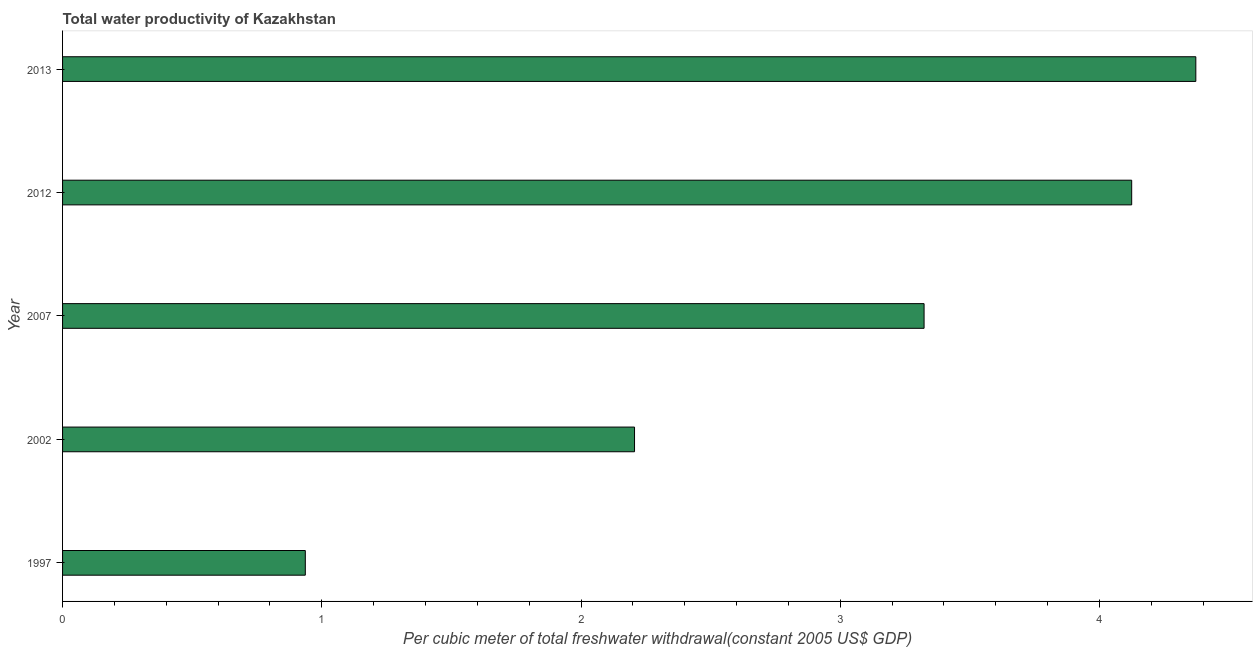Does the graph contain grids?
Provide a short and direct response. No. What is the title of the graph?
Give a very brief answer. Total water productivity of Kazakhstan. What is the label or title of the X-axis?
Your answer should be very brief. Per cubic meter of total freshwater withdrawal(constant 2005 US$ GDP). What is the total water productivity in 2012?
Your response must be concise. 4.12. Across all years, what is the maximum total water productivity?
Your answer should be very brief. 4.37. Across all years, what is the minimum total water productivity?
Offer a terse response. 0.94. What is the sum of the total water productivity?
Offer a terse response. 14.96. What is the difference between the total water productivity in 2012 and 2013?
Provide a short and direct response. -0.25. What is the average total water productivity per year?
Give a very brief answer. 2.99. What is the median total water productivity?
Provide a succinct answer. 3.32. What is the ratio of the total water productivity in 1997 to that in 2012?
Ensure brevity in your answer.  0.23. What is the difference between the highest and the second highest total water productivity?
Your answer should be very brief. 0.25. Is the sum of the total water productivity in 2007 and 2013 greater than the maximum total water productivity across all years?
Offer a very short reply. Yes. What is the difference between the highest and the lowest total water productivity?
Your answer should be very brief. 3.44. In how many years, is the total water productivity greater than the average total water productivity taken over all years?
Make the answer very short. 3. How many years are there in the graph?
Your answer should be compact. 5. Are the values on the major ticks of X-axis written in scientific E-notation?
Give a very brief answer. No. What is the Per cubic meter of total freshwater withdrawal(constant 2005 US$ GDP) of 1997?
Your answer should be compact. 0.94. What is the Per cubic meter of total freshwater withdrawal(constant 2005 US$ GDP) in 2002?
Offer a very short reply. 2.21. What is the Per cubic meter of total freshwater withdrawal(constant 2005 US$ GDP) of 2007?
Offer a terse response. 3.32. What is the Per cubic meter of total freshwater withdrawal(constant 2005 US$ GDP) of 2012?
Offer a very short reply. 4.12. What is the Per cubic meter of total freshwater withdrawal(constant 2005 US$ GDP) in 2013?
Give a very brief answer. 4.37. What is the difference between the Per cubic meter of total freshwater withdrawal(constant 2005 US$ GDP) in 1997 and 2002?
Offer a very short reply. -1.27. What is the difference between the Per cubic meter of total freshwater withdrawal(constant 2005 US$ GDP) in 1997 and 2007?
Give a very brief answer. -2.39. What is the difference between the Per cubic meter of total freshwater withdrawal(constant 2005 US$ GDP) in 1997 and 2012?
Ensure brevity in your answer.  -3.19. What is the difference between the Per cubic meter of total freshwater withdrawal(constant 2005 US$ GDP) in 1997 and 2013?
Ensure brevity in your answer.  -3.44. What is the difference between the Per cubic meter of total freshwater withdrawal(constant 2005 US$ GDP) in 2002 and 2007?
Provide a succinct answer. -1.12. What is the difference between the Per cubic meter of total freshwater withdrawal(constant 2005 US$ GDP) in 2002 and 2012?
Give a very brief answer. -1.92. What is the difference between the Per cubic meter of total freshwater withdrawal(constant 2005 US$ GDP) in 2002 and 2013?
Offer a terse response. -2.17. What is the difference between the Per cubic meter of total freshwater withdrawal(constant 2005 US$ GDP) in 2007 and 2012?
Your answer should be very brief. -0.8. What is the difference between the Per cubic meter of total freshwater withdrawal(constant 2005 US$ GDP) in 2007 and 2013?
Ensure brevity in your answer.  -1.05. What is the difference between the Per cubic meter of total freshwater withdrawal(constant 2005 US$ GDP) in 2012 and 2013?
Ensure brevity in your answer.  -0.25. What is the ratio of the Per cubic meter of total freshwater withdrawal(constant 2005 US$ GDP) in 1997 to that in 2002?
Your response must be concise. 0.42. What is the ratio of the Per cubic meter of total freshwater withdrawal(constant 2005 US$ GDP) in 1997 to that in 2007?
Offer a very short reply. 0.28. What is the ratio of the Per cubic meter of total freshwater withdrawal(constant 2005 US$ GDP) in 1997 to that in 2012?
Provide a short and direct response. 0.23. What is the ratio of the Per cubic meter of total freshwater withdrawal(constant 2005 US$ GDP) in 1997 to that in 2013?
Offer a very short reply. 0.21. What is the ratio of the Per cubic meter of total freshwater withdrawal(constant 2005 US$ GDP) in 2002 to that in 2007?
Make the answer very short. 0.66. What is the ratio of the Per cubic meter of total freshwater withdrawal(constant 2005 US$ GDP) in 2002 to that in 2012?
Offer a terse response. 0.54. What is the ratio of the Per cubic meter of total freshwater withdrawal(constant 2005 US$ GDP) in 2002 to that in 2013?
Your answer should be very brief. 0.51. What is the ratio of the Per cubic meter of total freshwater withdrawal(constant 2005 US$ GDP) in 2007 to that in 2012?
Ensure brevity in your answer.  0.81. What is the ratio of the Per cubic meter of total freshwater withdrawal(constant 2005 US$ GDP) in 2007 to that in 2013?
Offer a terse response. 0.76. What is the ratio of the Per cubic meter of total freshwater withdrawal(constant 2005 US$ GDP) in 2012 to that in 2013?
Give a very brief answer. 0.94. 